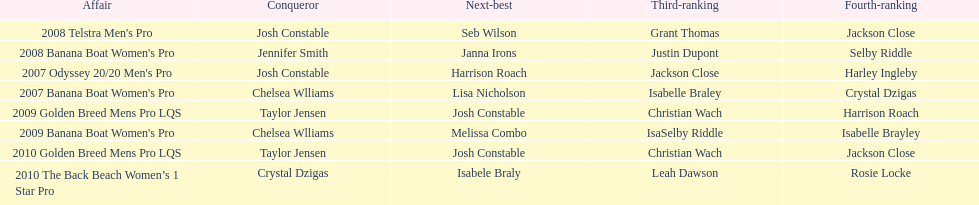Who came in immediately after josh constable in the 2008 telstra men's pro? Seb Wilson. 